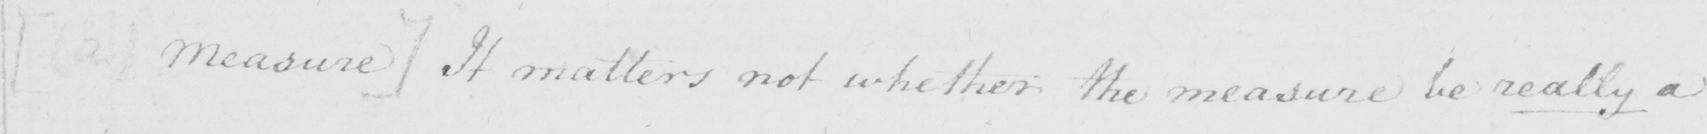Can you tell me what this handwritten text says? [  ( a )  Measure ]  It matters not whether the measure be really a 